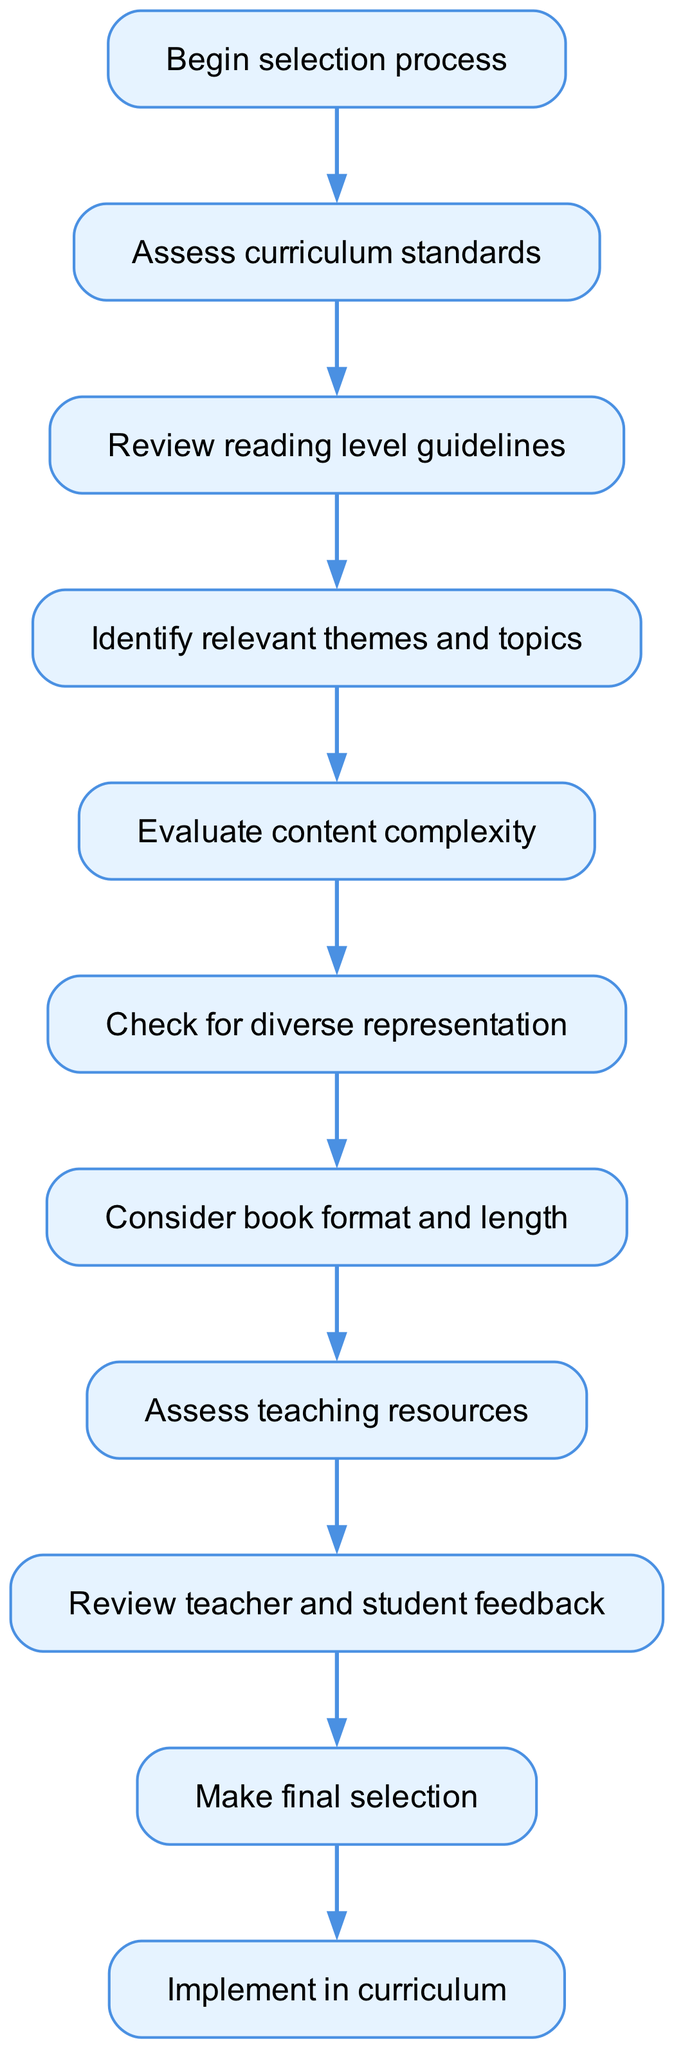What is the first step in the selection process? The diagram indicates the first step in the selection process is labeled as "Begin selection process."
Answer: Begin selection process How many nodes are present in the diagram? By counting each distinct action or decision point outlined in the diagram, a total of 11 nodes can be identified, numbered from start to end.
Answer: 11 What comes after 'Review reading level guidelines'? Following the 'Review reading level guidelines' node, the next step in the flow is 'Identify relevant themes and topics.'
Answer: Identify relevant themes and topics What aspect does 'Check for diverse representation' focus on? The node 'Check for diverse representation' focuses on ensuring that the reading materials include a variety of perspectives and backgrounds, promoting inclusivity in selected texts.
Answer: Diverse representation Which node immediately precedes the 'Make final selection'? The diagram shows that 'Review teacher and student feedback' is the node that comes immediately before 'Make final selection.'
Answer: Review teacher and student feedback How many connections are there leading out from 'Consider book format and length'? Reviewing the connections from the 'Consider book format and length' node, there is one outgoing connection that leads to 'Assess teaching resources.'
Answer: 1 What is the final outcome of the selection process? According to the flow diagram, the final outcome of the selection process is identified as 'Implement in curriculum.'
Answer: Implement in curriculum What does 'Evaluate content complexity' assess? The 'Evaluate content complexity' node assesses the difficulty and sophistication of the reading material to ensure it is appropriate for the intended grade level.
Answer: Content complexity In this flow chart, what is done after assessing the curriculum standards? After 'Assess curriculum standards,' the subsequent step is 'Review reading level guidelines,' which indicates a progression in the decision-making process.
Answer: Review reading level guidelines 